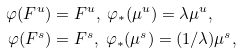<formula> <loc_0><loc_0><loc_500><loc_500>\varphi ( F ^ { u } ) & = F ^ { u } , \ \varphi _ { * } ( \mu ^ { u } ) = \lambda \mu ^ { u } , \\ \varphi ( F ^ { s } ) & = F ^ { s } , \ \varphi _ { * } ( \mu ^ { s } ) = ( 1 / \lambda ) \mu ^ { s } ,</formula> 